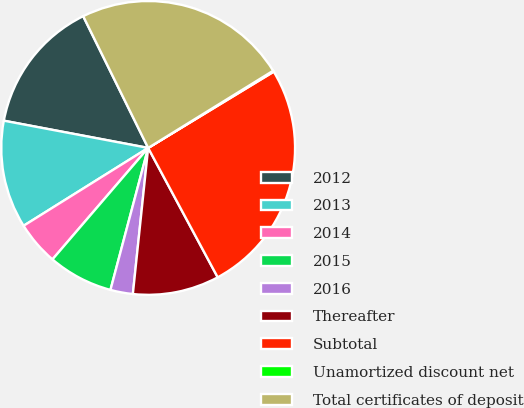<chart> <loc_0><loc_0><loc_500><loc_500><pie_chart><fcel>2012<fcel>2013<fcel>2014<fcel>2015<fcel>2016<fcel>Thereafter<fcel>Subtotal<fcel>Unamortized discount net<fcel>Total certificates of deposit<nl><fcel>14.74%<fcel>11.86%<fcel>4.82%<fcel>7.16%<fcel>2.47%<fcel>9.51%<fcel>25.84%<fcel>0.12%<fcel>23.49%<nl></chart> 